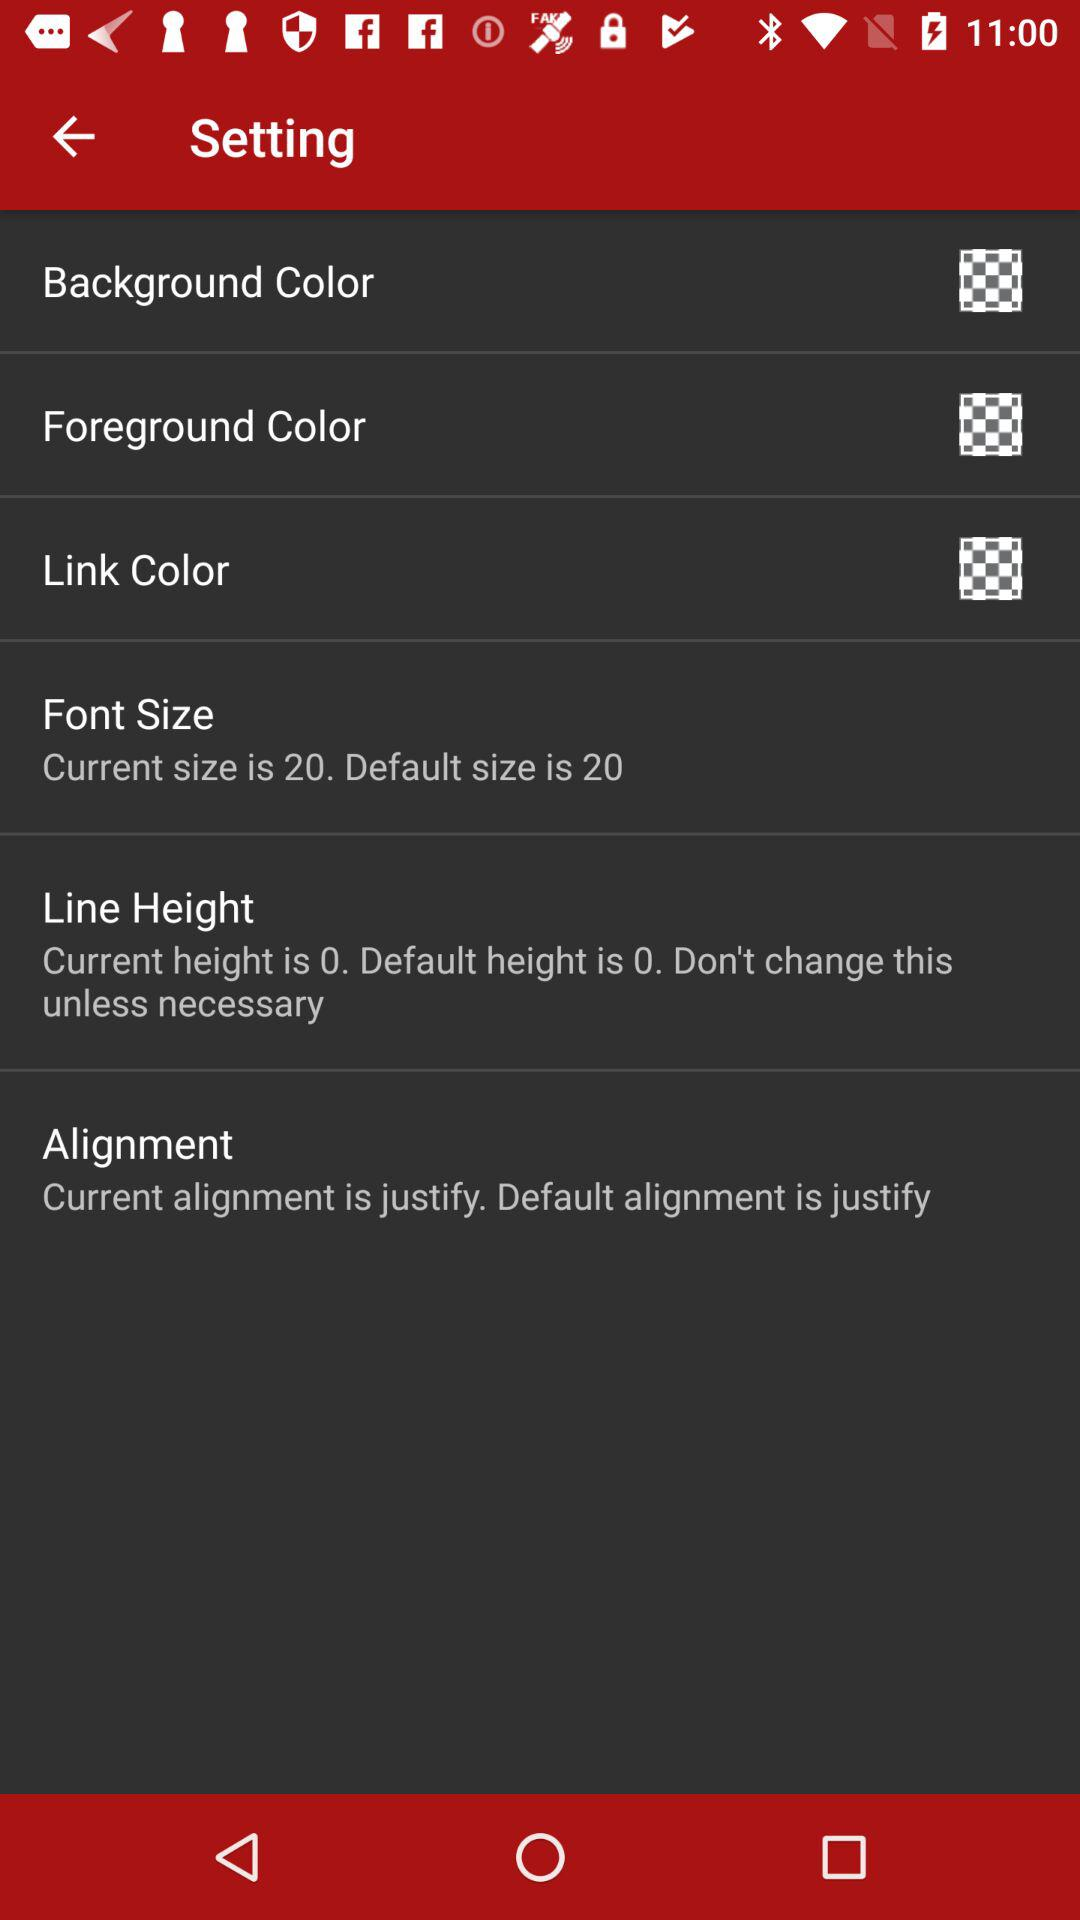What is the selected font size? The selected font size is 20. 